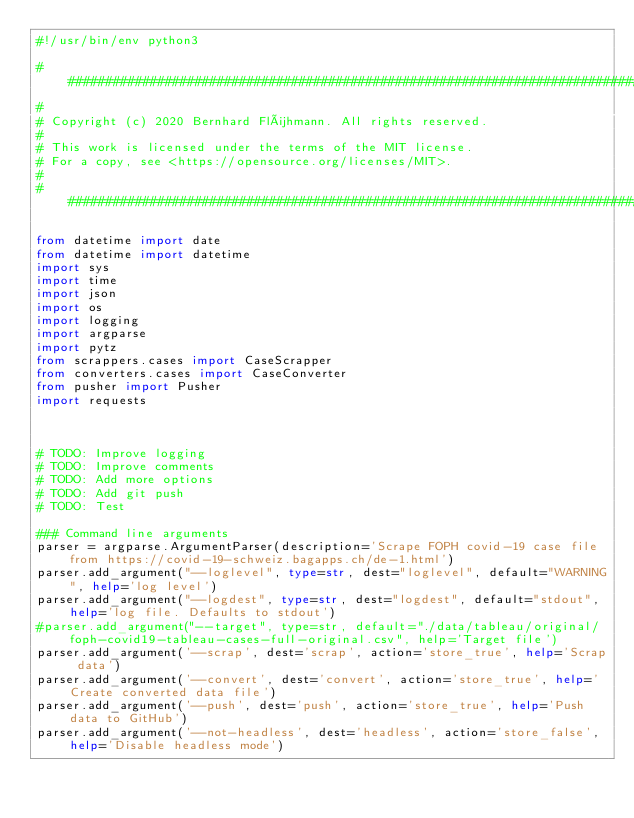Convert code to text. <code><loc_0><loc_0><loc_500><loc_500><_Python_>#!/usr/bin/env python3

#####################################################################################################################
# 
# Copyright (c) 2020 Bernhard Flühmann. All rights reserved.
#
# This work is licensed under the terms of the MIT license.  
# For a copy, see <https://opensource.org/licenses/MIT>.
#
######################################################################################################################

from datetime import date
from datetime import datetime
import sys
import time
import json
import os
import logging
import argparse
import pytz
from scrappers.cases import CaseScrapper
from converters.cases import CaseConverter
from pusher import Pusher
import requests



# TODO: Improve logging
# TODO: Improve comments
# TODO: Add more options
# TODO: Add git push
# TODO: Test

### Command line arguments
parser = argparse.ArgumentParser(description='Scrape FOPH covid-19 case file from https://covid-19-schweiz.bagapps.ch/de-1.html')
parser.add_argument("--loglevel", type=str, dest="loglevel", default="WARNING", help='log level')
parser.add_argument("--logdest", type=str, dest="logdest", default="stdout", help='log file. Defaults to stdout')
#parser.add_argument("--target", type=str, default="./data/tableau/original/foph-covid19-tableau-cases-full-original.csv", help='Target file')
parser.add_argument('--scrap', dest='scrap', action='store_true', help='Scrap data')
parser.add_argument('--convert', dest='convert', action='store_true', help='Create converted data file')
parser.add_argument('--push', dest='push', action='store_true', help='Push data to GitHub')
parser.add_argument('--not-headless', dest='headless', action='store_false', help='Disable headless mode')</code> 